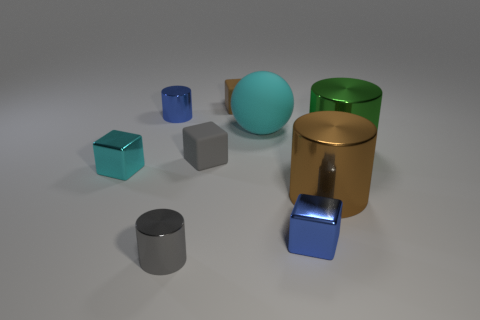Do the cyan cube and the gray cylinder have the same size?
Ensure brevity in your answer.  Yes. There is a small blue thing behind the tiny blue metal object that is right of the big cyan matte thing; is there a large metallic thing in front of it?
Your answer should be very brief. Yes. There is a gray thing that is the same shape as the small brown matte object; what is its material?
Provide a short and direct response. Rubber. What is the color of the shiny cube in front of the brown cylinder?
Your answer should be compact. Blue. The blue cube has what size?
Your answer should be compact. Small. There is a gray metallic object; is its size the same as the blue object in front of the big brown thing?
Your answer should be very brief. Yes. There is a small cylinder in front of the blue object in front of the big shiny object that is behind the brown cylinder; what is its color?
Ensure brevity in your answer.  Gray. Are the blue block left of the big brown metal cylinder and the tiny cyan block made of the same material?
Your answer should be compact. Yes. What number of other things are the same material as the small blue block?
Your response must be concise. 5. What is the material of the green object that is the same size as the cyan rubber object?
Ensure brevity in your answer.  Metal. 